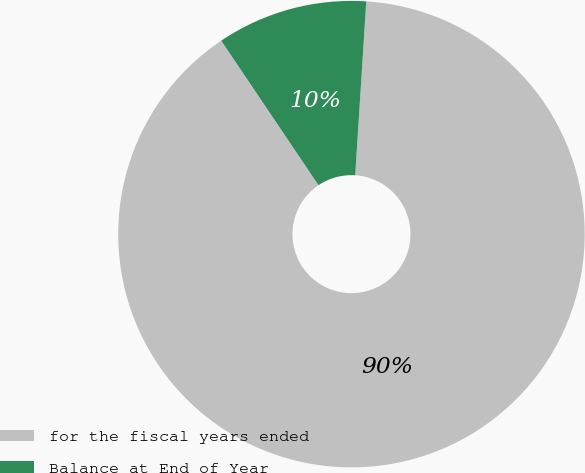Convert chart to OTSL. <chart><loc_0><loc_0><loc_500><loc_500><pie_chart><fcel>for the fiscal years ended<fcel>Balance at End of Year<nl><fcel>89.56%<fcel>10.44%<nl></chart> 